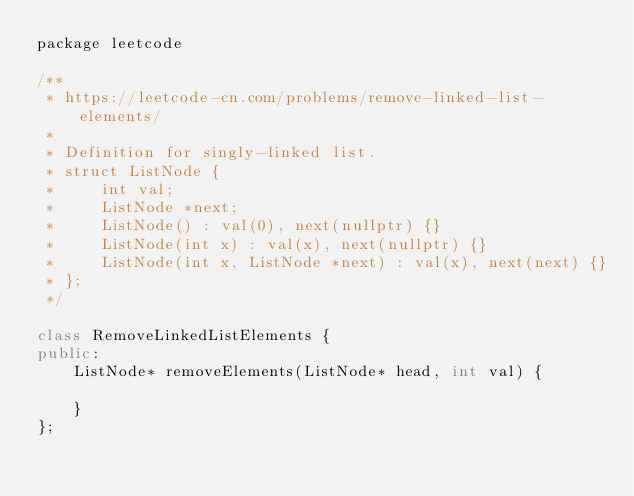Convert code to text. <code><loc_0><loc_0><loc_500><loc_500><_C++_>package leetcode

/**
 * https://leetcode-cn.com/problems/remove-linked-list-elements/
 *
 * Definition for singly-linked list.
 * struct ListNode {
 *     int val;
 *     ListNode *next;
 *     ListNode() : val(0), next(nullptr) {}
 *     ListNode(int x) : val(x), next(nullptr) {}
 *     ListNode(int x, ListNode *next) : val(x), next(next) {}
 * };
 */

class RemoveLinkedListElements {
public:
    ListNode* removeElements(ListNode* head, int val) {

    }
};</code> 